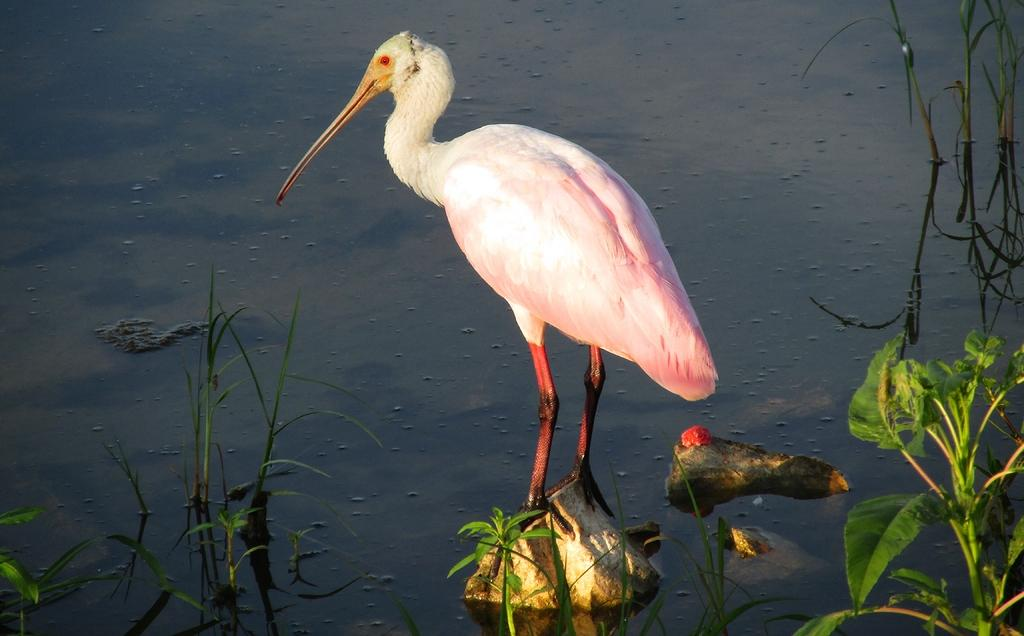What is the main subject in the image? There is a crane in the image. What is the crane standing on? The crane is standing on a stone. What type of vegetation can be seen in the image? There are plants in the image. What other objects are present in the image besides the crane and plants? There are stones and water at the bottom of the image. How many copies of the ring can be seen in the image? There is no ring present in the image. 